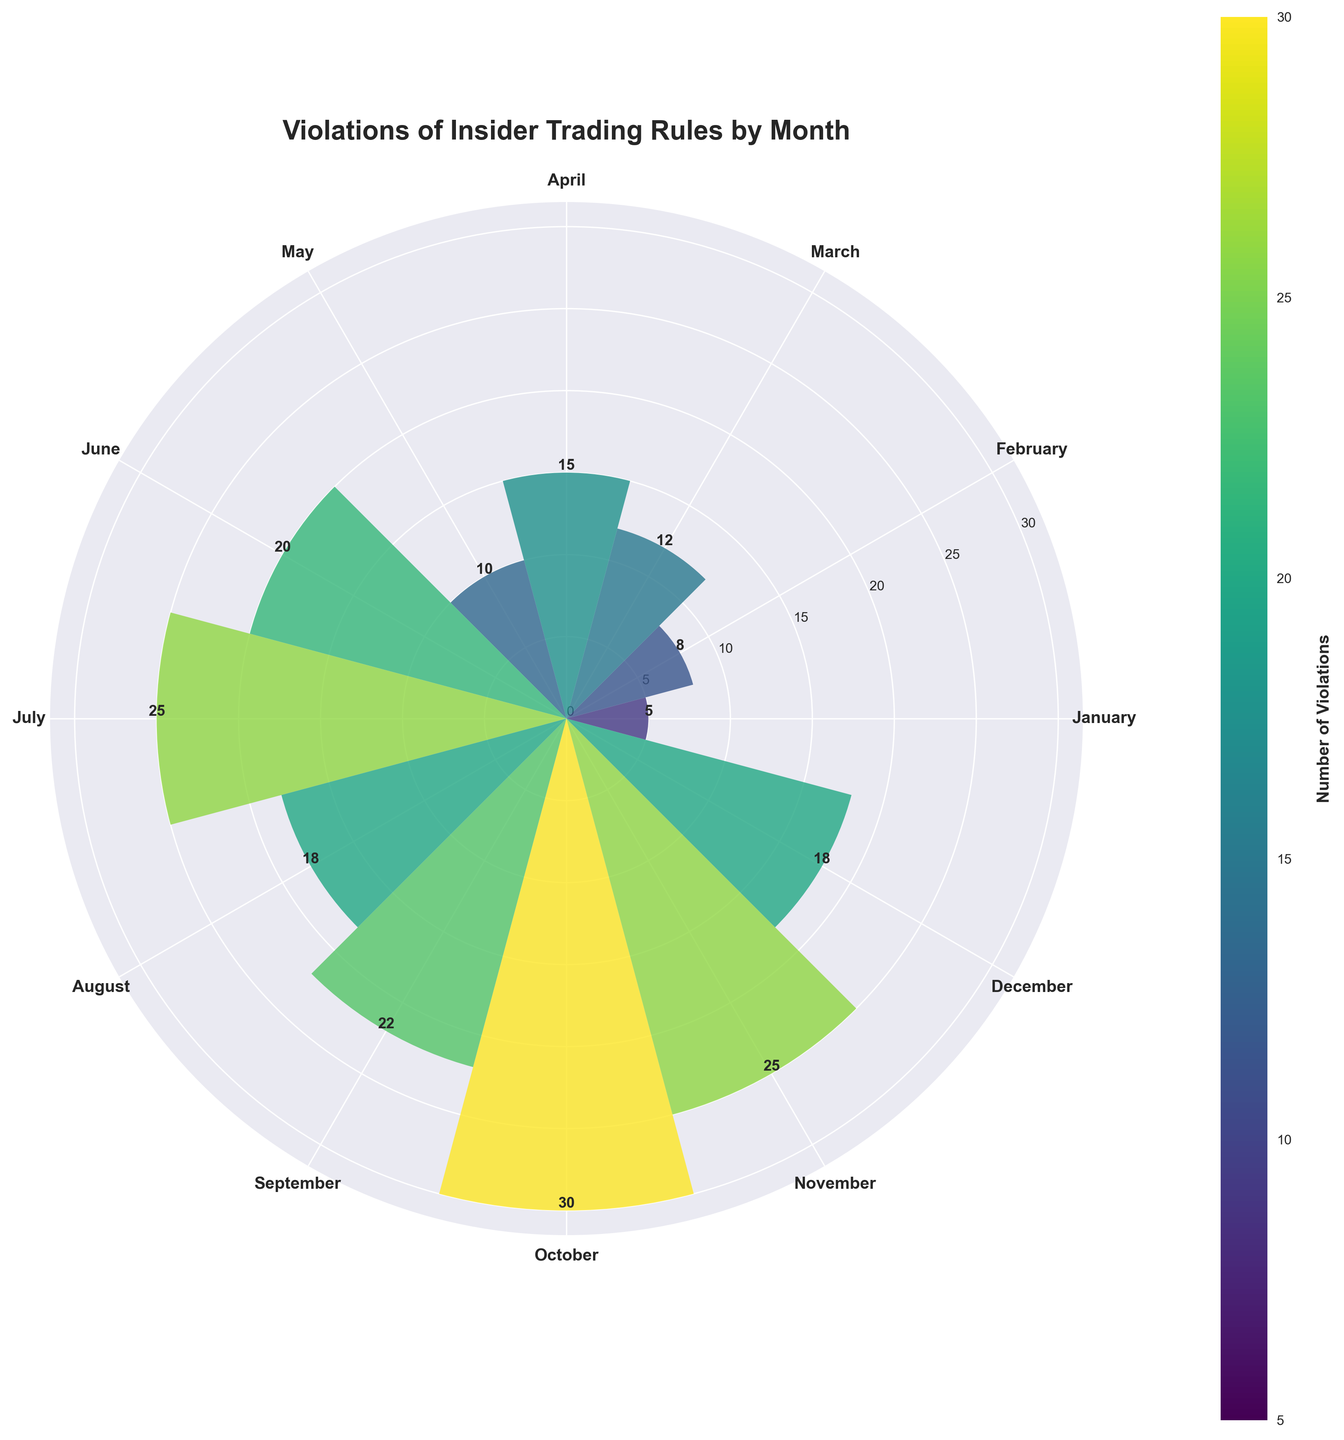How many months have 25 violations? Count the number of bars that reach the height of 25 in the plot. Two bars, representing July and November, reach 25 violations.
Answer: 2 During which month were the most violations recorded? Identify the month with the tallest bar. October has the highest bar indicating 30 violations.
Answer: October What is the difference in violations between October and January? Subtract the number of violations in January from the number of violations in October. October has 30 violations and January has 5, making the difference 30 - 5 = 25.
Answer: 25 Which month(s) had a number of violations equal to May? Compare the height of the bar for May with other bars. May has 10 violations. January is the only other month with 10 violations.
Answer: January What is the mean number of violations across all months? Sum all the violations and divide by the number of months. Sum = 5 + 8 + 12 + 15 + 10 + 20 + 25 + 18 + 22 + 30 + 25 + 18 = 208; mean = 208 / 12 ≈ 17.33.
Answer: 17.33 Which months have more than 20 violations? Identify the months where the height of the bars is above the 20 mark. June, July, September, October, and November have more than 20 violations.
Answer: June, July, September, October, November What is the sum of the violations in the third and fourth quarters of the year? Sum the violations from July to December. 25 + 18 + 22 + 30 + 25 + 18 = 138.
Answer: 138 How do the color gradients relate to the number of violations? The bars' colors change gradient based on the number of violations, with lighter colors representing fewer violations and darker colors representing more violations, as indicated by the color scale.
Answer: Darker colors represent more violations Which quarter has the least violations? Sum the violations for each quarter and compare. Q1 (Jan-Mar): 5 + 8 + 12 = 25, Q2 (Apr-Jun): 15 + 10 + 20 = 45, Q3 (Jul-Sep): 25 + 18 + 22 = 65, Q4 (Oct-Dec): 30 + 25 + 18 = 73. Q1 has the least violations.
Answer: Q1 (Jan-Mar) On average, how many violations occur in the second half of the year? Sum the violations from July to December and divide by 6. Sum = 25 + 18 + 22 + 30 + 25 + 18 = 138; mean = 138 / 6 = 23.
Answer: 23 